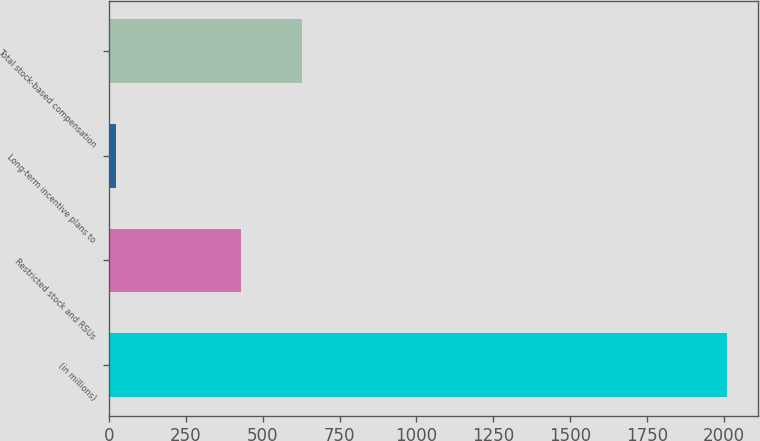Convert chart. <chart><loc_0><loc_0><loc_500><loc_500><bar_chart><fcel>(in millions)<fcel>Restricted stock and RSUs<fcel>Long-term incentive plans to<fcel>Total stock-based compensation<nl><fcel>2012<fcel>429<fcel>22<fcel>628<nl></chart> 